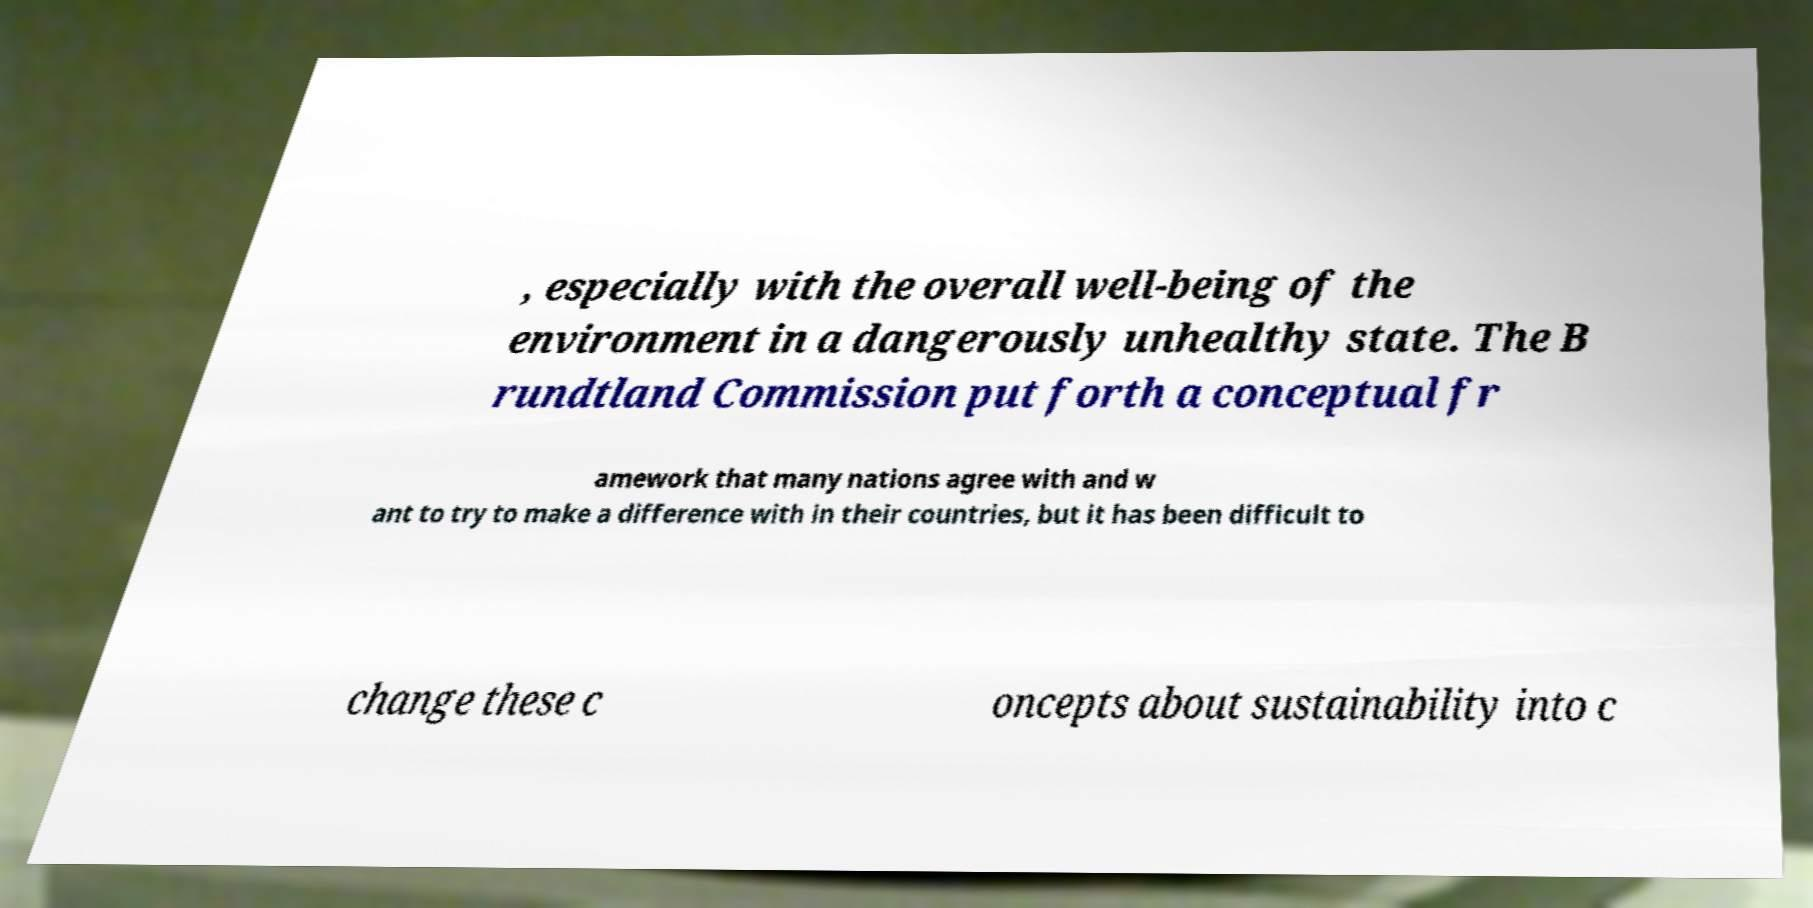I need the written content from this picture converted into text. Can you do that? , especially with the overall well-being of the environment in a dangerously unhealthy state. The B rundtland Commission put forth a conceptual fr amework that many nations agree with and w ant to try to make a difference with in their countries, but it has been difficult to change these c oncepts about sustainability into c 